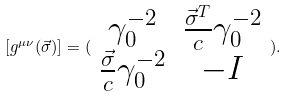<formula> <loc_0><loc_0><loc_500><loc_500>[ g ^ { \mu \nu } ( \vec { \sigma } ) ] = ( \begin{array} { c c } \gamma _ { 0 } ^ { - 2 } & \frac { \vec { \sigma } ^ { T } } { c } \gamma _ { 0 } ^ { - 2 } \\ \frac { \vec { \sigma } } { c } \gamma _ { 0 } ^ { - 2 } & - I \end{array} ) .</formula> 